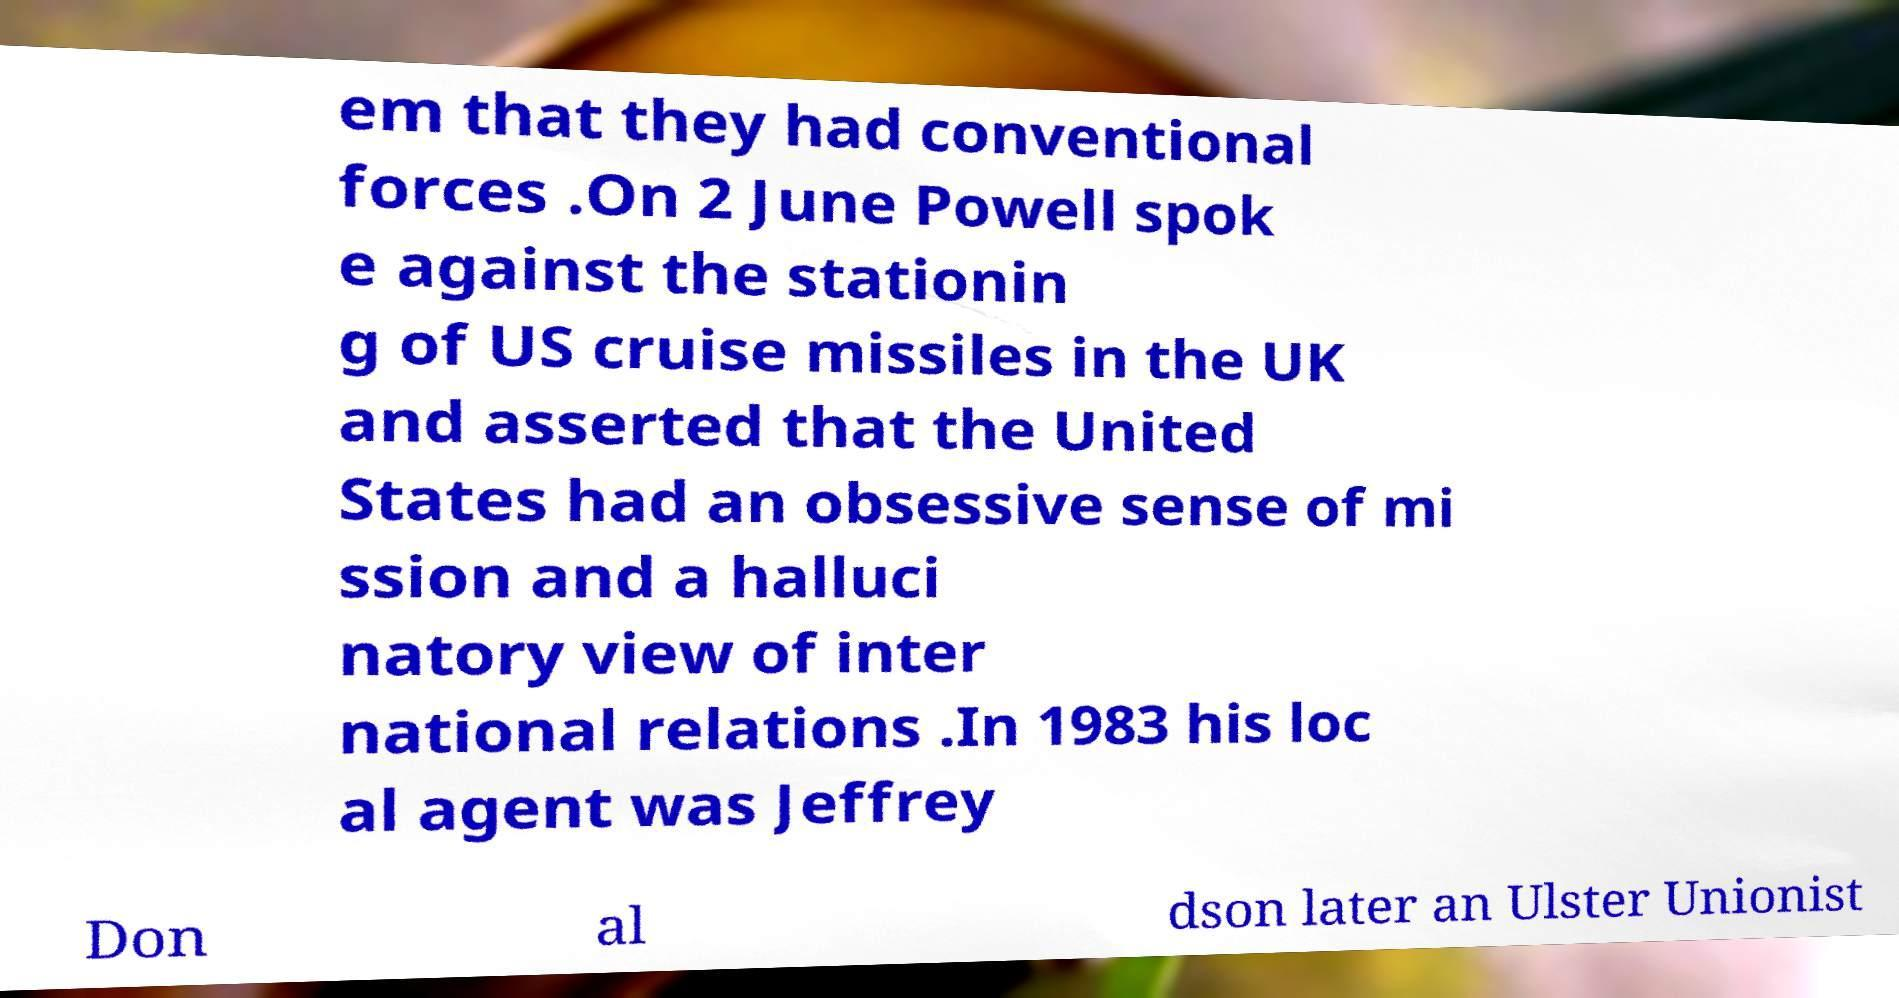Can you read and provide the text displayed in the image?This photo seems to have some interesting text. Can you extract and type it out for me? em that they had conventional forces .On 2 June Powell spok e against the stationin g of US cruise missiles in the UK and asserted that the United States had an obsessive sense of mi ssion and a halluci natory view of inter national relations .In 1983 his loc al agent was Jeffrey Don al dson later an Ulster Unionist 